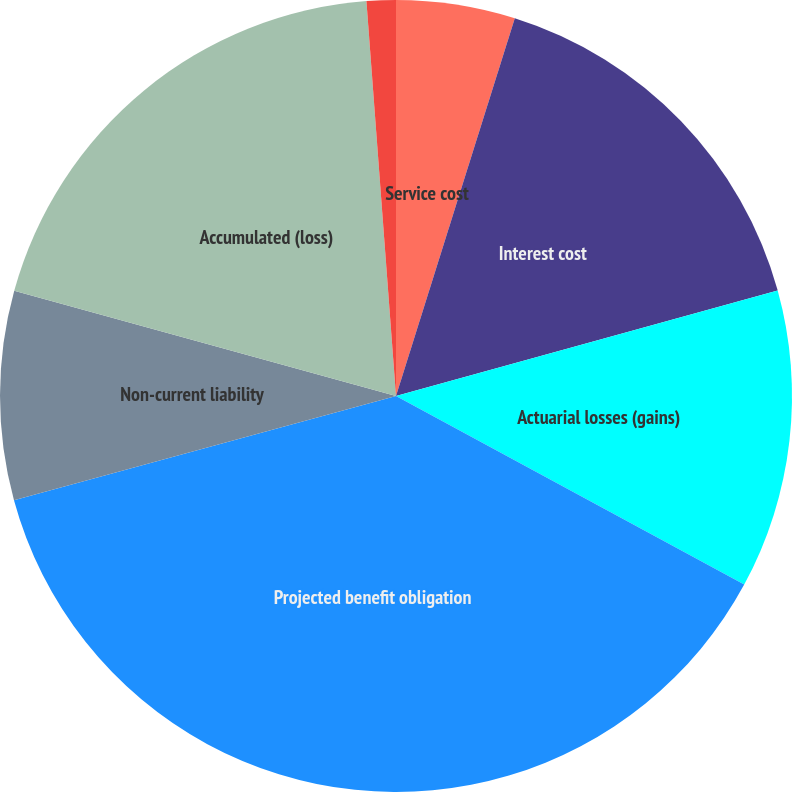Convert chart. <chart><loc_0><loc_0><loc_500><loc_500><pie_chart><fcel>Service cost<fcel>Interest cost<fcel>Actuarial losses (gains)<fcel>Projected benefit obligation<fcel>Non-current liability<fcel>Accumulated (loss)<fcel>Discount rate<nl><fcel>4.85%<fcel>15.86%<fcel>12.19%<fcel>37.86%<fcel>8.52%<fcel>19.53%<fcel>1.19%<nl></chart> 